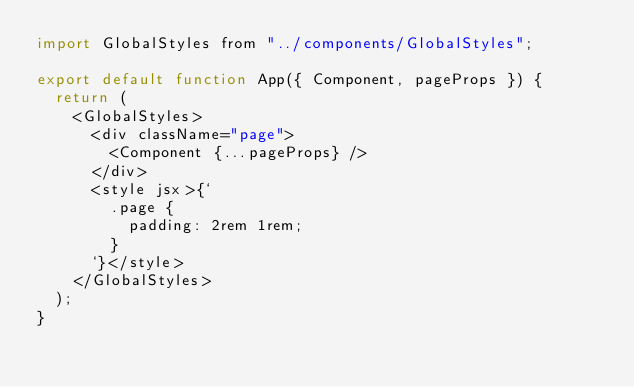Convert code to text. <code><loc_0><loc_0><loc_500><loc_500><_JavaScript_>import GlobalStyles from "../components/GlobalStyles";

export default function App({ Component, pageProps }) {
  return (
    <GlobalStyles>
      <div className="page">
        <Component {...pageProps} />
      </div>
      <style jsx>{`
        .page {
          padding: 2rem 1rem;
        }
      `}</style>
    </GlobalStyles>
  );
}
</code> 